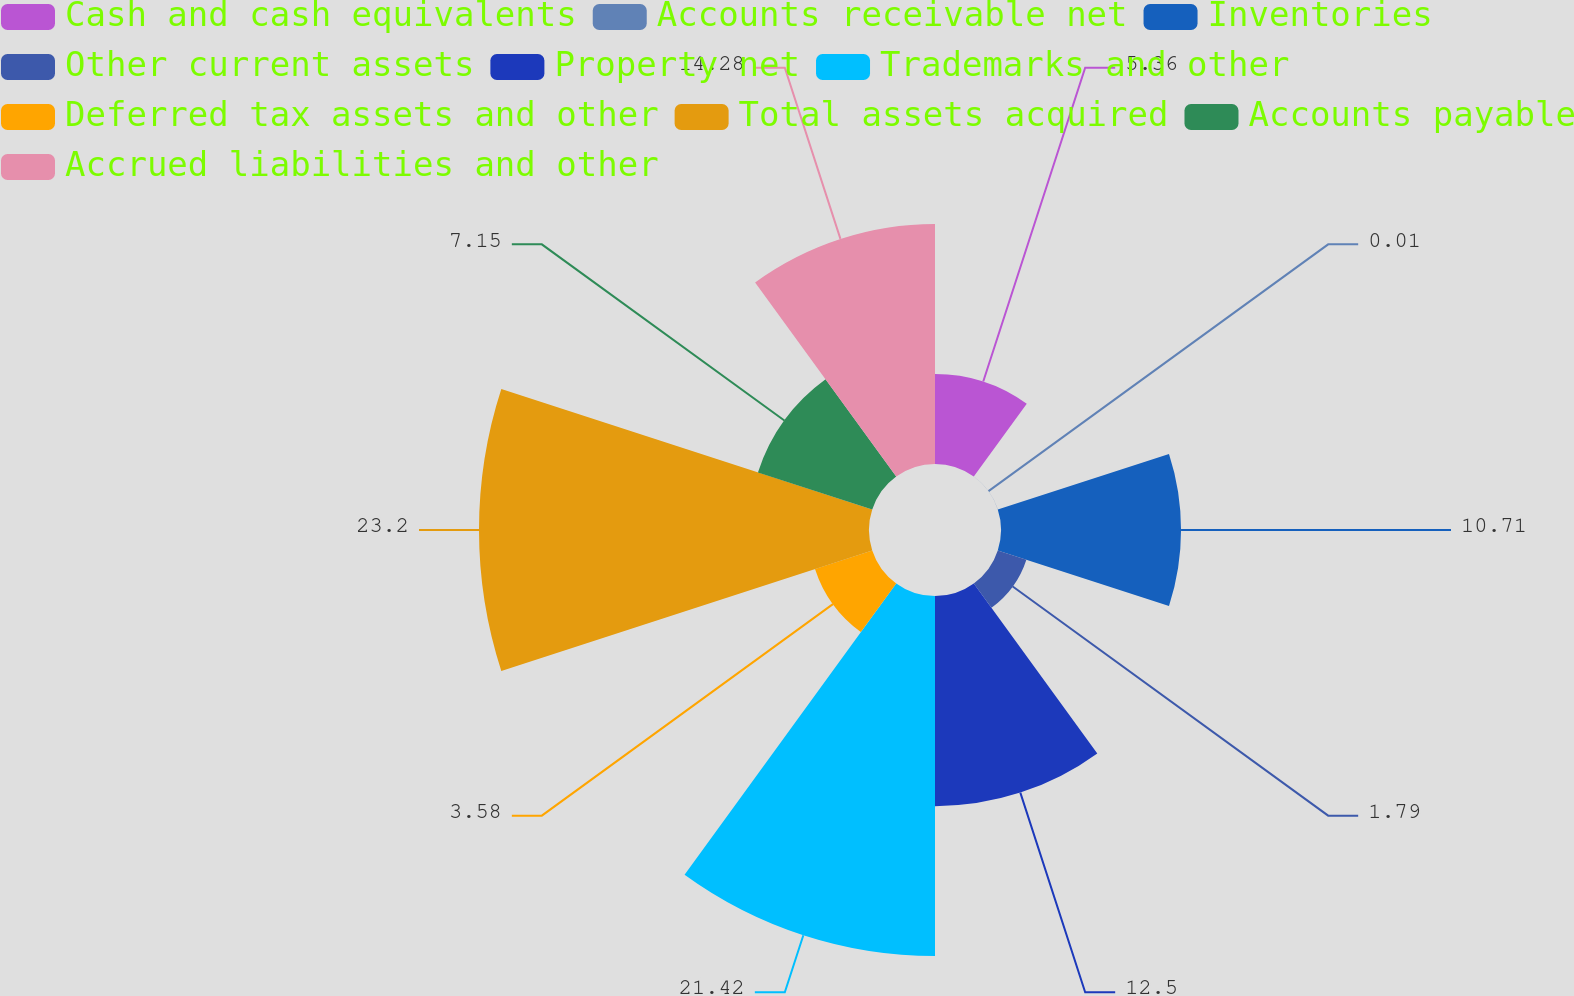Convert chart. <chart><loc_0><loc_0><loc_500><loc_500><pie_chart><fcel>Cash and cash equivalents<fcel>Accounts receivable net<fcel>Inventories<fcel>Other current assets<fcel>Property net<fcel>Trademarks and other<fcel>Deferred tax assets and other<fcel>Total assets acquired<fcel>Accounts payable<fcel>Accrued liabilities and other<nl><fcel>5.36%<fcel>0.01%<fcel>10.71%<fcel>1.79%<fcel>12.5%<fcel>21.42%<fcel>3.58%<fcel>23.2%<fcel>7.15%<fcel>14.28%<nl></chart> 